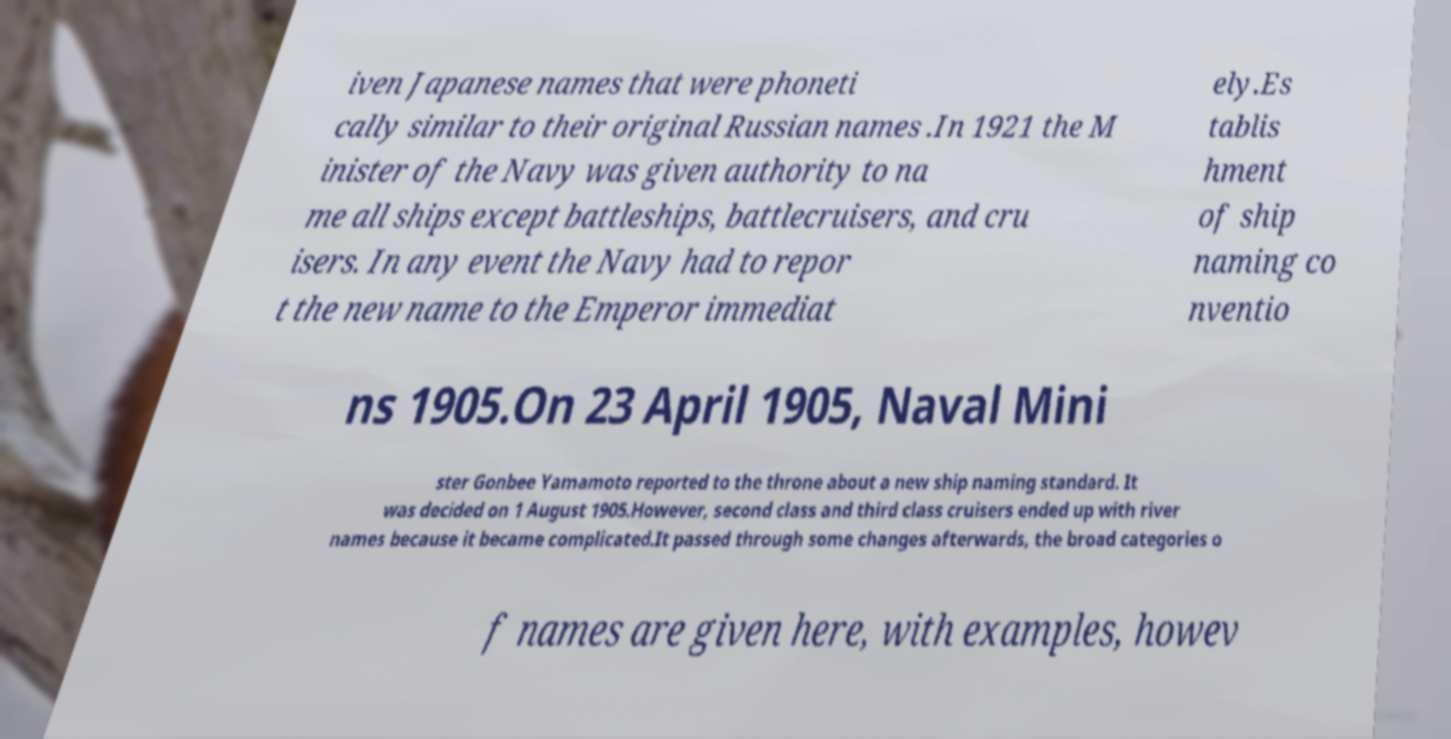Could you assist in decoding the text presented in this image and type it out clearly? iven Japanese names that were phoneti cally similar to their original Russian names .In 1921 the M inister of the Navy was given authority to na me all ships except battleships, battlecruisers, and cru isers. In any event the Navy had to repor t the new name to the Emperor immediat ely.Es tablis hment of ship naming co nventio ns 1905.On 23 April 1905, Naval Mini ster Gonbee Yamamoto reported to the throne about a new ship naming standard. It was decided on 1 August 1905.However, second class and third class cruisers ended up with river names because it became complicated.It passed through some changes afterwards, the broad categories o f names are given here, with examples, howev 